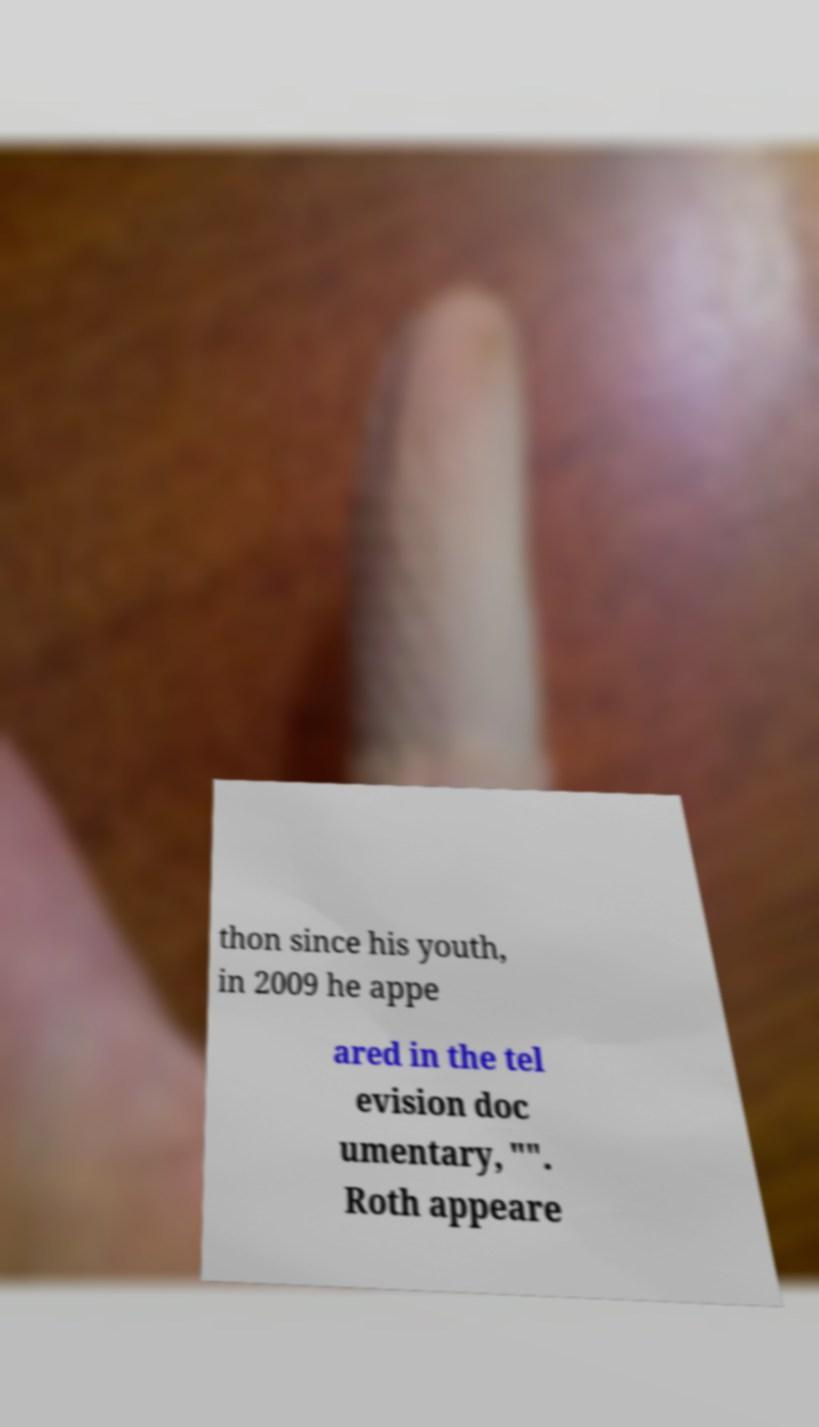Please read and relay the text visible in this image. What does it say? thon since his youth, in 2009 he appe ared in the tel evision doc umentary, "". Roth appeare 